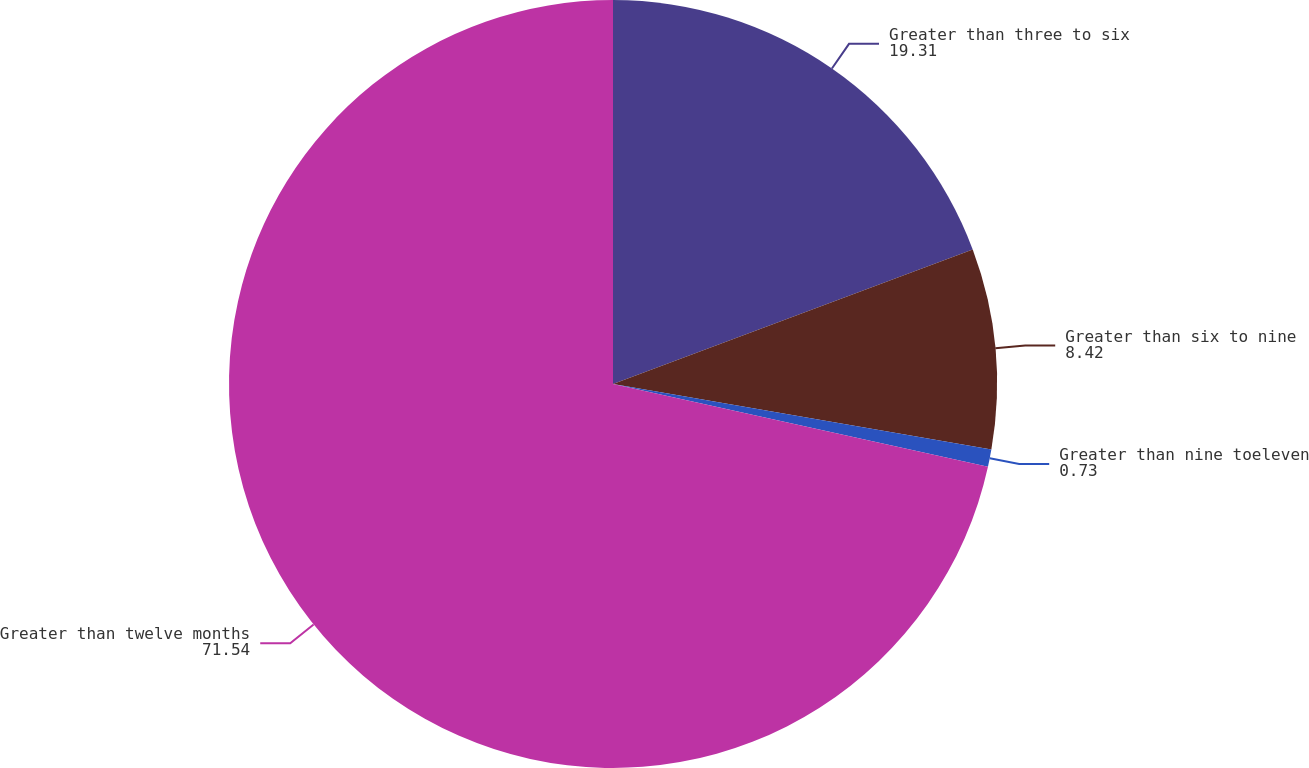Convert chart. <chart><loc_0><loc_0><loc_500><loc_500><pie_chart><fcel>Greater than three to six<fcel>Greater than six to nine<fcel>Greater than nine toeleven<fcel>Greater than twelve months<nl><fcel>19.31%<fcel>8.42%<fcel>0.73%<fcel>71.54%<nl></chart> 